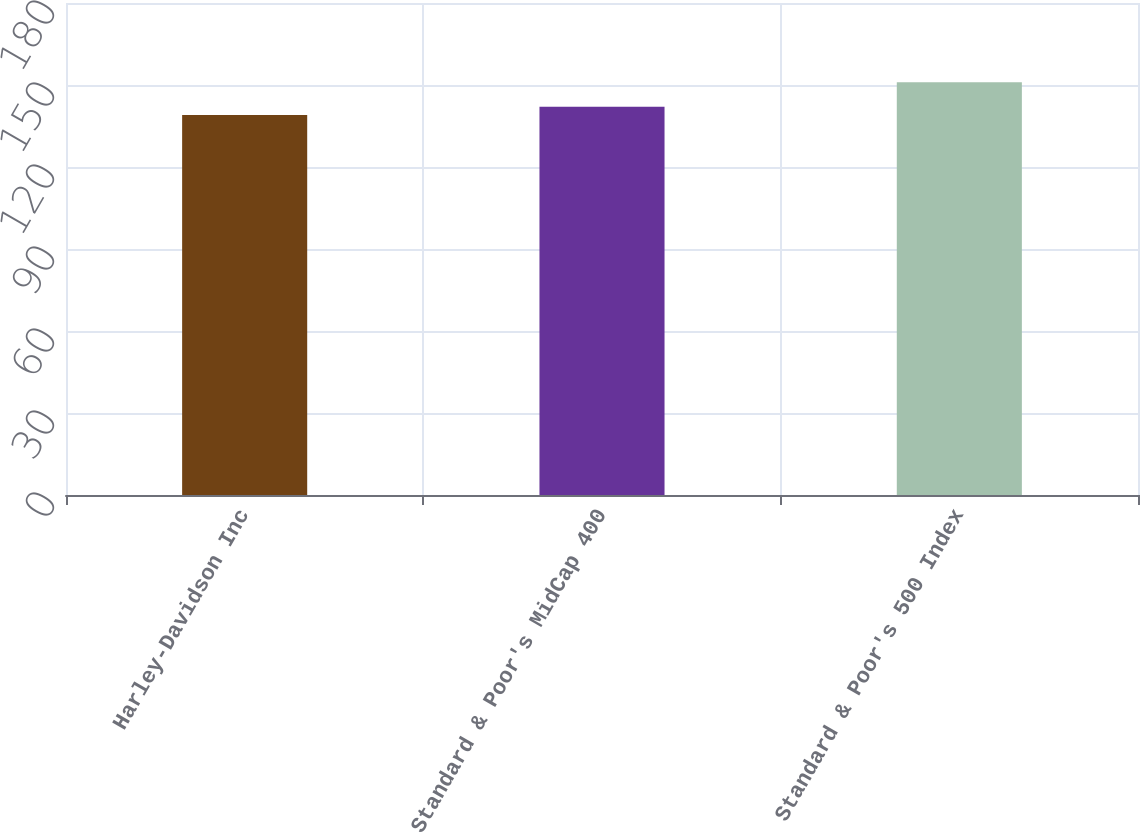Convert chart to OTSL. <chart><loc_0><loc_0><loc_500><loc_500><bar_chart><fcel>Harley-Davidson Inc<fcel>Standard & Poor's MidCap 400<fcel>Standard & Poor's 500 Index<nl><fcel>139<fcel>142<fcel>151<nl></chart> 